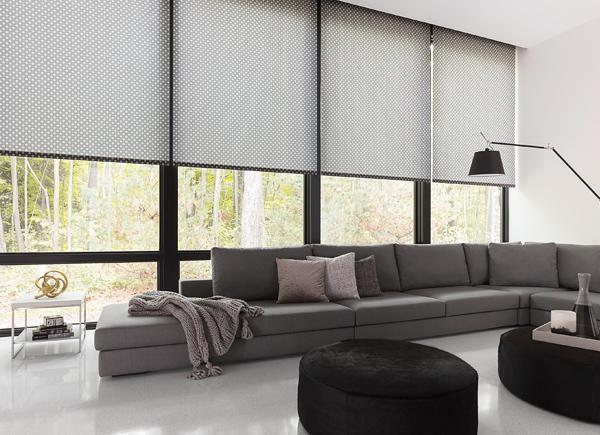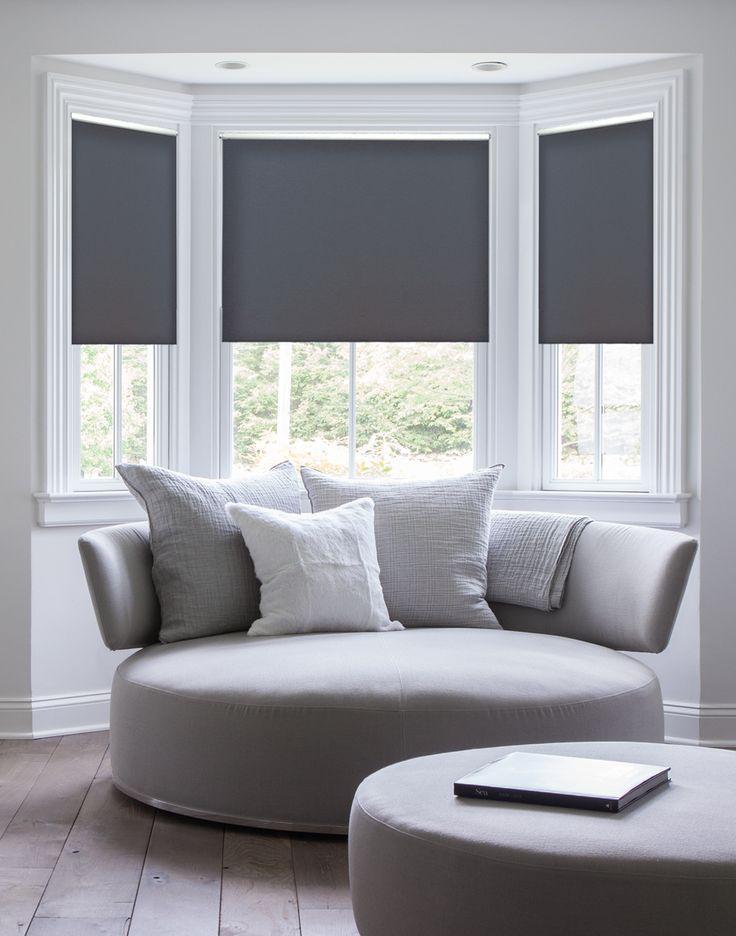The first image is the image on the left, the second image is the image on the right. Considering the images on both sides, is "In the image to the left, you can see the lamp." valid? Answer yes or no. Yes. The first image is the image on the left, the second image is the image on the right. Examine the images to the left and right. Is the description "There are three window shades in one image, and four window shades in the other image." accurate? Answer yes or no. Yes. 